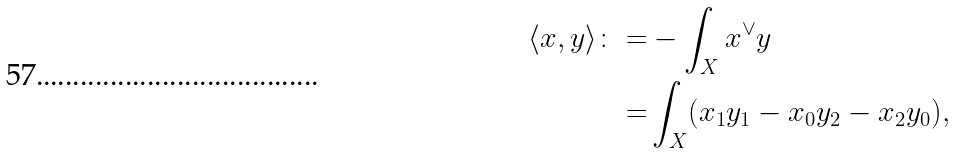Convert formula to latex. <formula><loc_0><loc_0><loc_500><loc_500>\langle x , y \rangle \colon = & - \int _ { X } x ^ { \vee } y \\ = & \int _ { X } ( x _ { 1 } y _ { 1 } - x _ { 0 } y _ { 2 } - x _ { 2 } y _ { 0 } ) ,</formula> 